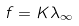<formula> <loc_0><loc_0><loc_500><loc_500>f = K \lambda _ { \infty }</formula> 